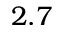<formula> <loc_0><loc_0><loc_500><loc_500>2 . 7</formula> 